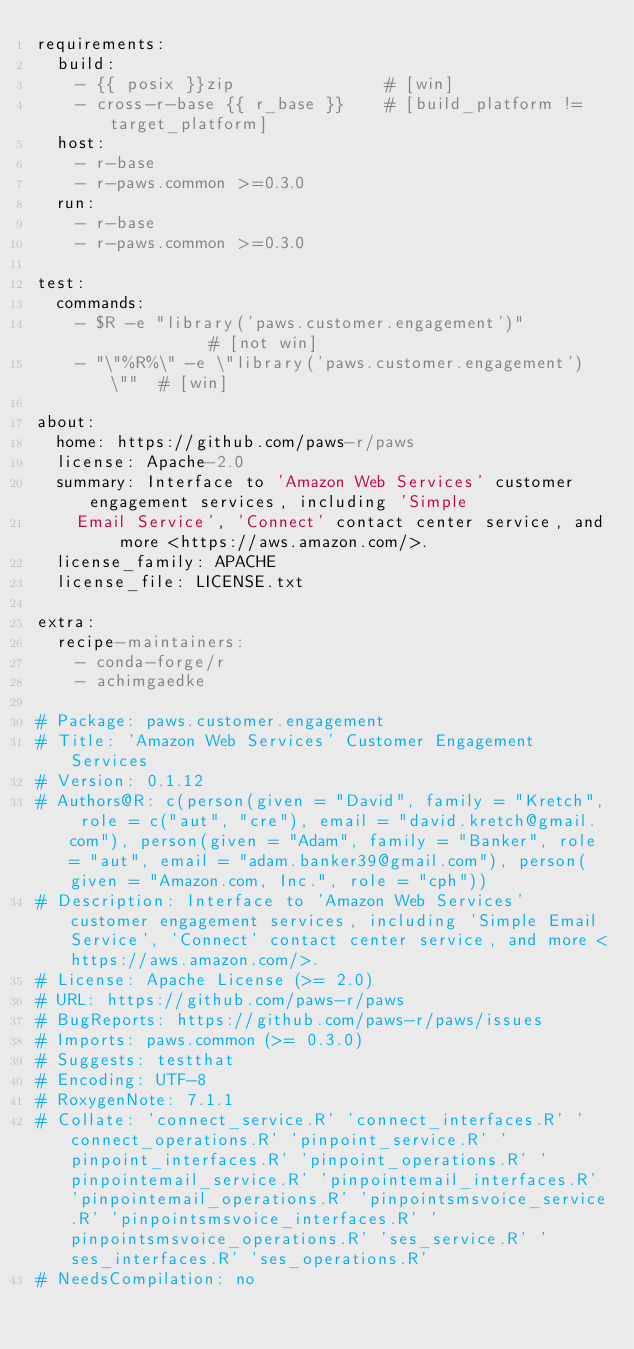<code> <loc_0><loc_0><loc_500><loc_500><_YAML_>requirements:
  build:
    - {{ posix }}zip               # [win]
    - cross-r-base {{ r_base }}    # [build_platform != target_platform]
  host:
    - r-base
    - r-paws.common >=0.3.0
  run:
    - r-base
    - r-paws.common >=0.3.0

test:
  commands:
    - $R -e "library('paws.customer.engagement')"           # [not win]
    - "\"%R%\" -e \"library('paws.customer.engagement')\""  # [win]

about:
  home: https://github.com/paws-r/paws
  license: Apache-2.0
  summary: Interface to 'Amazon Web Services' customer engagement services, including 'Simple
    Email Service', 'Connect' contact center service, and more <https://aws.amazon.com/>.
  license_family: APACHE
  license_file: LICENSE.txt

extra:
  recipe-maintainers:
    - conda-forge/r
    - achimgaedke

# Package: paws.customer.engagement
# Title: 'Amazon Web Services' Customer Engagement Services
# Version: 0.1.12
# Authors@R: c(person(given = "David", family = "Kretch", role = c("aut", "cre"), email = "david.kretch@gmail.com"), person(given = "Adam", family = "Banker", role = "aut", email = "adam.banker39@gmail.com"), person(given = "Amazon.com, Inc.", role = "cph"))
# Description: Interface to 'Amazon Web Services' customer engagement services, including 'Simple Email Service', 'Connect' contact center service, and more <https://aws.amazon.com/>.
# License: Apache License (>= 2.0)
# URL: https://github.com/paws-r/paws
# BugReports: https://github.com/paws-r/paws/issues
# Imports: paws.common (>= 0.3.0)
# Suggests: testthat
# Encoding: UTF-8
# RoxygenNote: 7.1.1
# Collate: 'connect_service.R' 'connect_interfaces.R' 'connect_operations.R' 'pinpoint_service.R' 'pinpoint_interfaces.R' 'pinpoint_operations.R' 'pinpointemail_service.R' 'pinpointemail_interfaces.R' 'pinpointemail_operations.R' 'pinpointsmsvoice_service.R' 'pinpointsmsvoice_interfaces.R' 'pinpointsmsvoice_operations.R' 'ses_service.R' 'ses_interfaces.R' 'ses_operations.R'
# NeedsCompilation: no</code> 